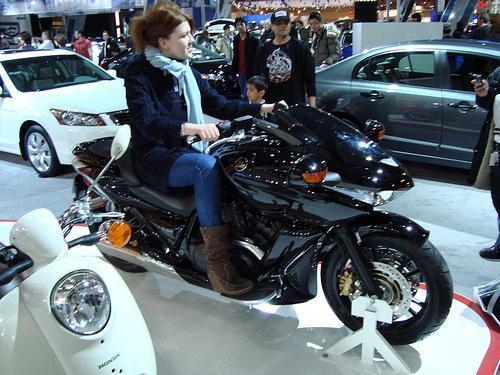How many wheels are on the black motorbike?
Give a very brief answer. 2. 